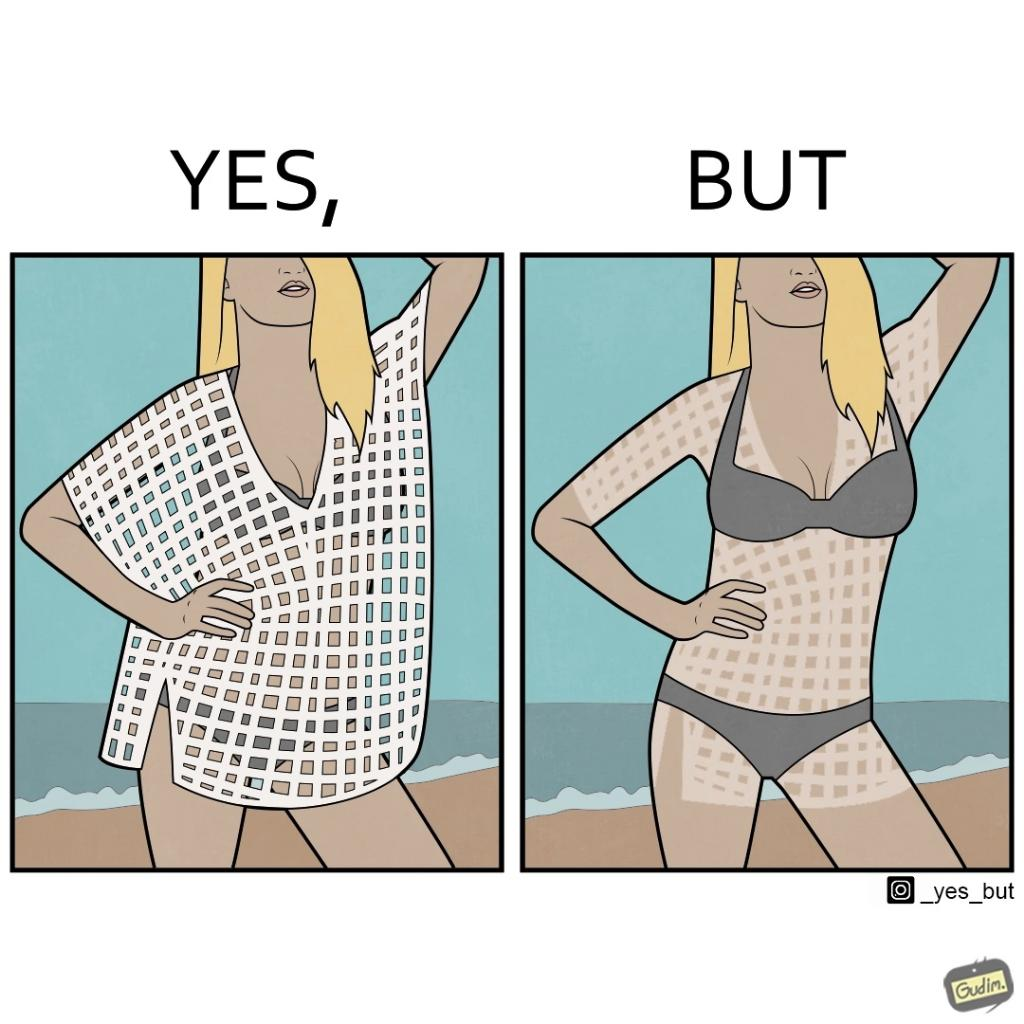What makes this image funny or satirical? Women wear netted tops while out in the sun on the beach as a beachwear, but when the person removes it, the skin is tanned in the same netted pattern looks weird, and goes against the purpose of using it as beachwear 